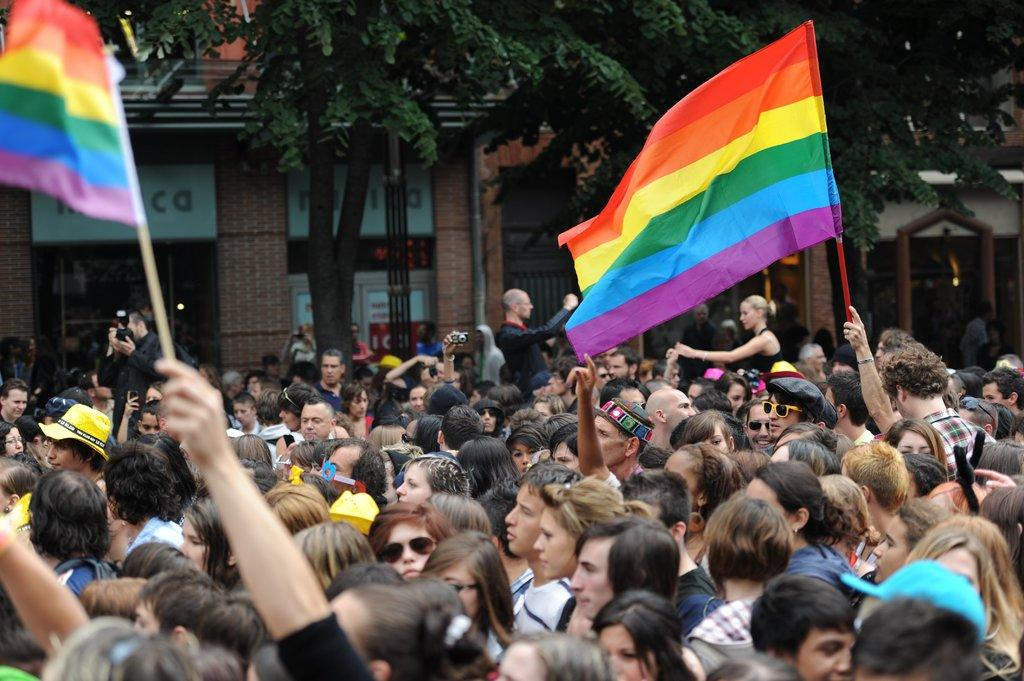What is the main subject in the foreground of the image? There is a crowd in the foreground of the image. What are two people in the crowd doing? Two people are holding flags in the air. What can be seen in the background of the image? There are buildings, trees, and posters in the background of the image. What type of stone is being used to express love in the image? There is no stone or expression of love present in the image. 